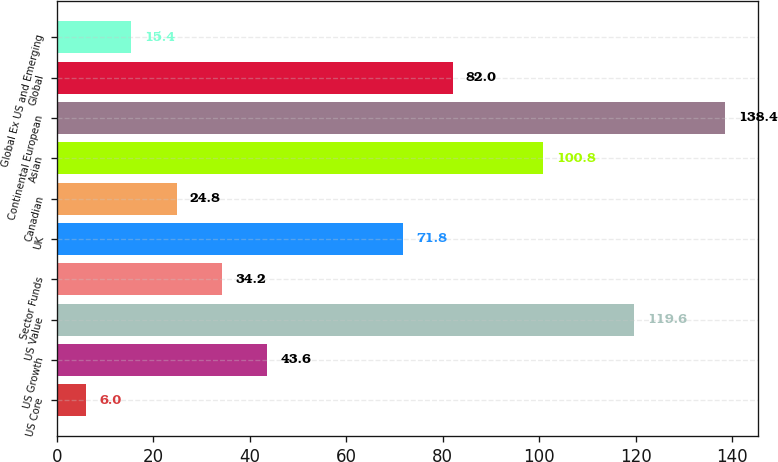Convert chart to OTSL. <chart><loc_0><loc_0><loc_500><loc_500><bar_chart><fcel>US Core<fcel>US Growth<fcel>US Value<fcel>Sector Funds<fcel>UK<fcel>Canadian<fcel>Asian<fcel>Continental European<fcel>Global<fcel>Global Ex US and Emerging<nl><fcel>6<fcel>43.6<fcel>119.6<fcel>34.2<fcel>71.8<fcel>24.8<fcel>100.8<fcel>138.4<fcel>82<fcel>15.4<nl></chart> 